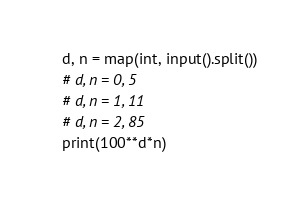Convert code to text. <code><loc_0><loc_0><loc_500><loc_500><_Python_>d, n = map(int, input().split())
# d, n = 0, 5
# d, n = 1, 11
# d, n = 2, 85
print(100**d*n)
</code> 